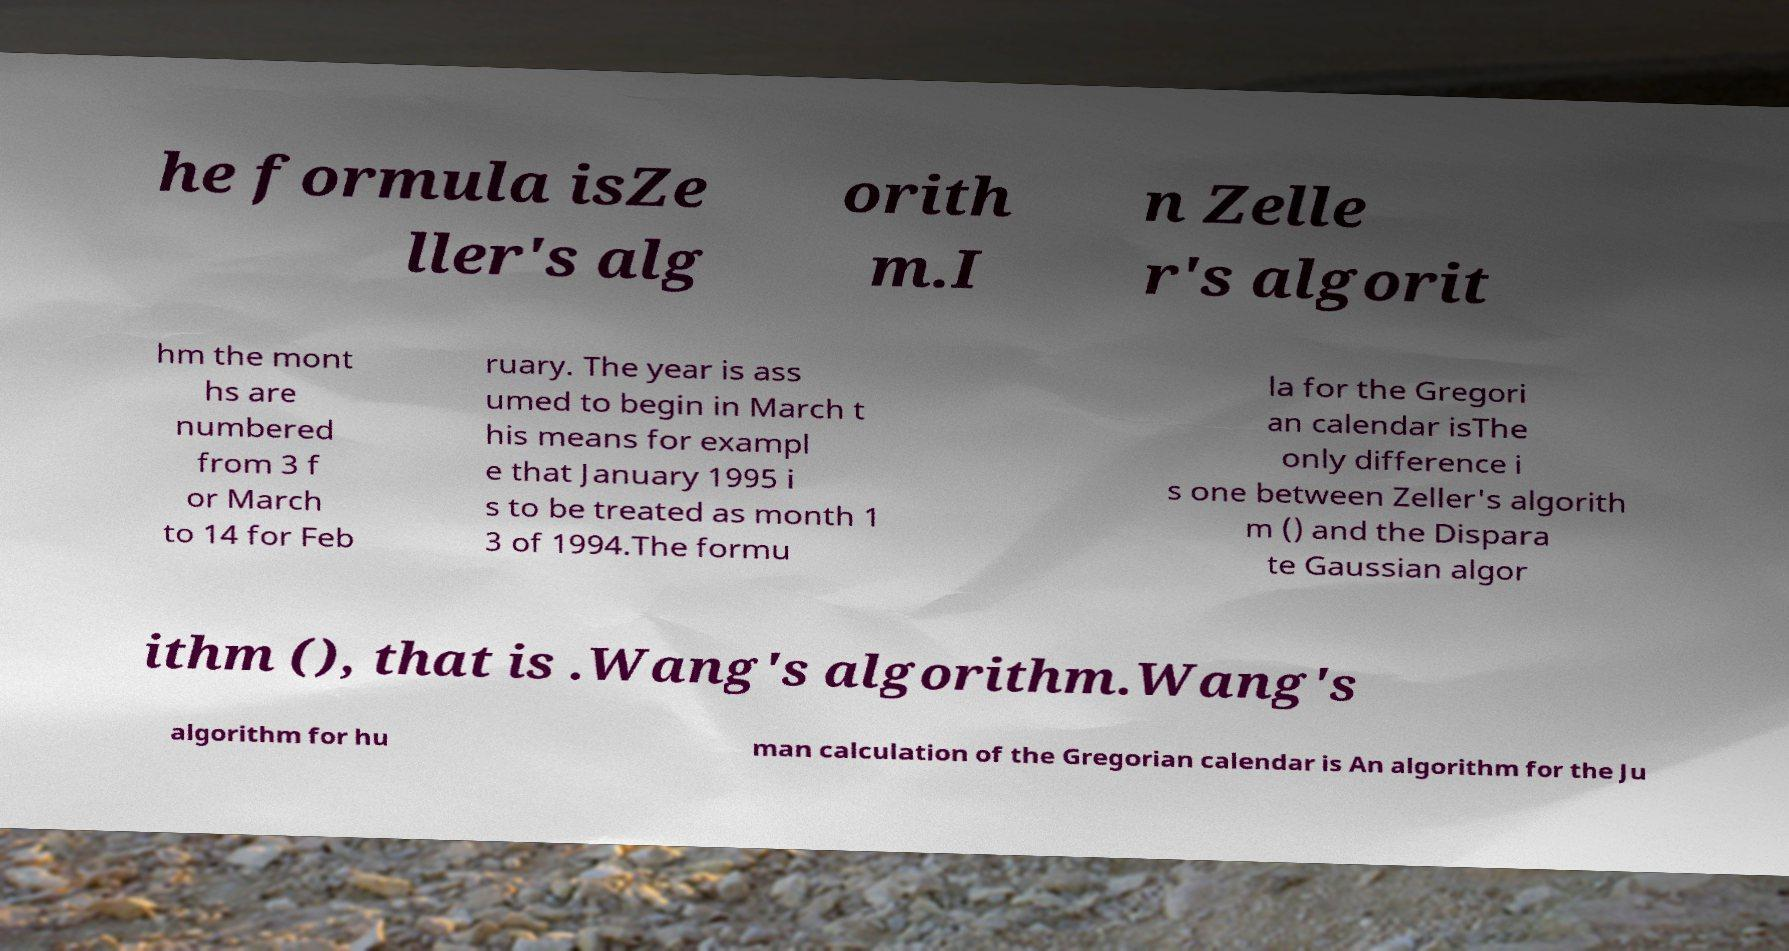Can you read and provide the text displayed in the image?This photo seems to have some interesting text. Can you extract and type it out for me? he formula isZe ller's alg orith m.I n Zelle r's algorit hm the mont hs are numbered from 3 f or March to 14 for Feb ruary. The year is ass umed to begin in March t his means for exampl e that January 1995 i s to be treated as month 1 3 of 1994.The formu la for the Gregori an calendar isThe only difference i s one between Zeller's algorith m () and the Dispara te Gaussian algor ithm (), that is .Wang's algorithm.Wang's algorithm for hu man calculation of the Gregorian calendar is An algorithm for the Ju 